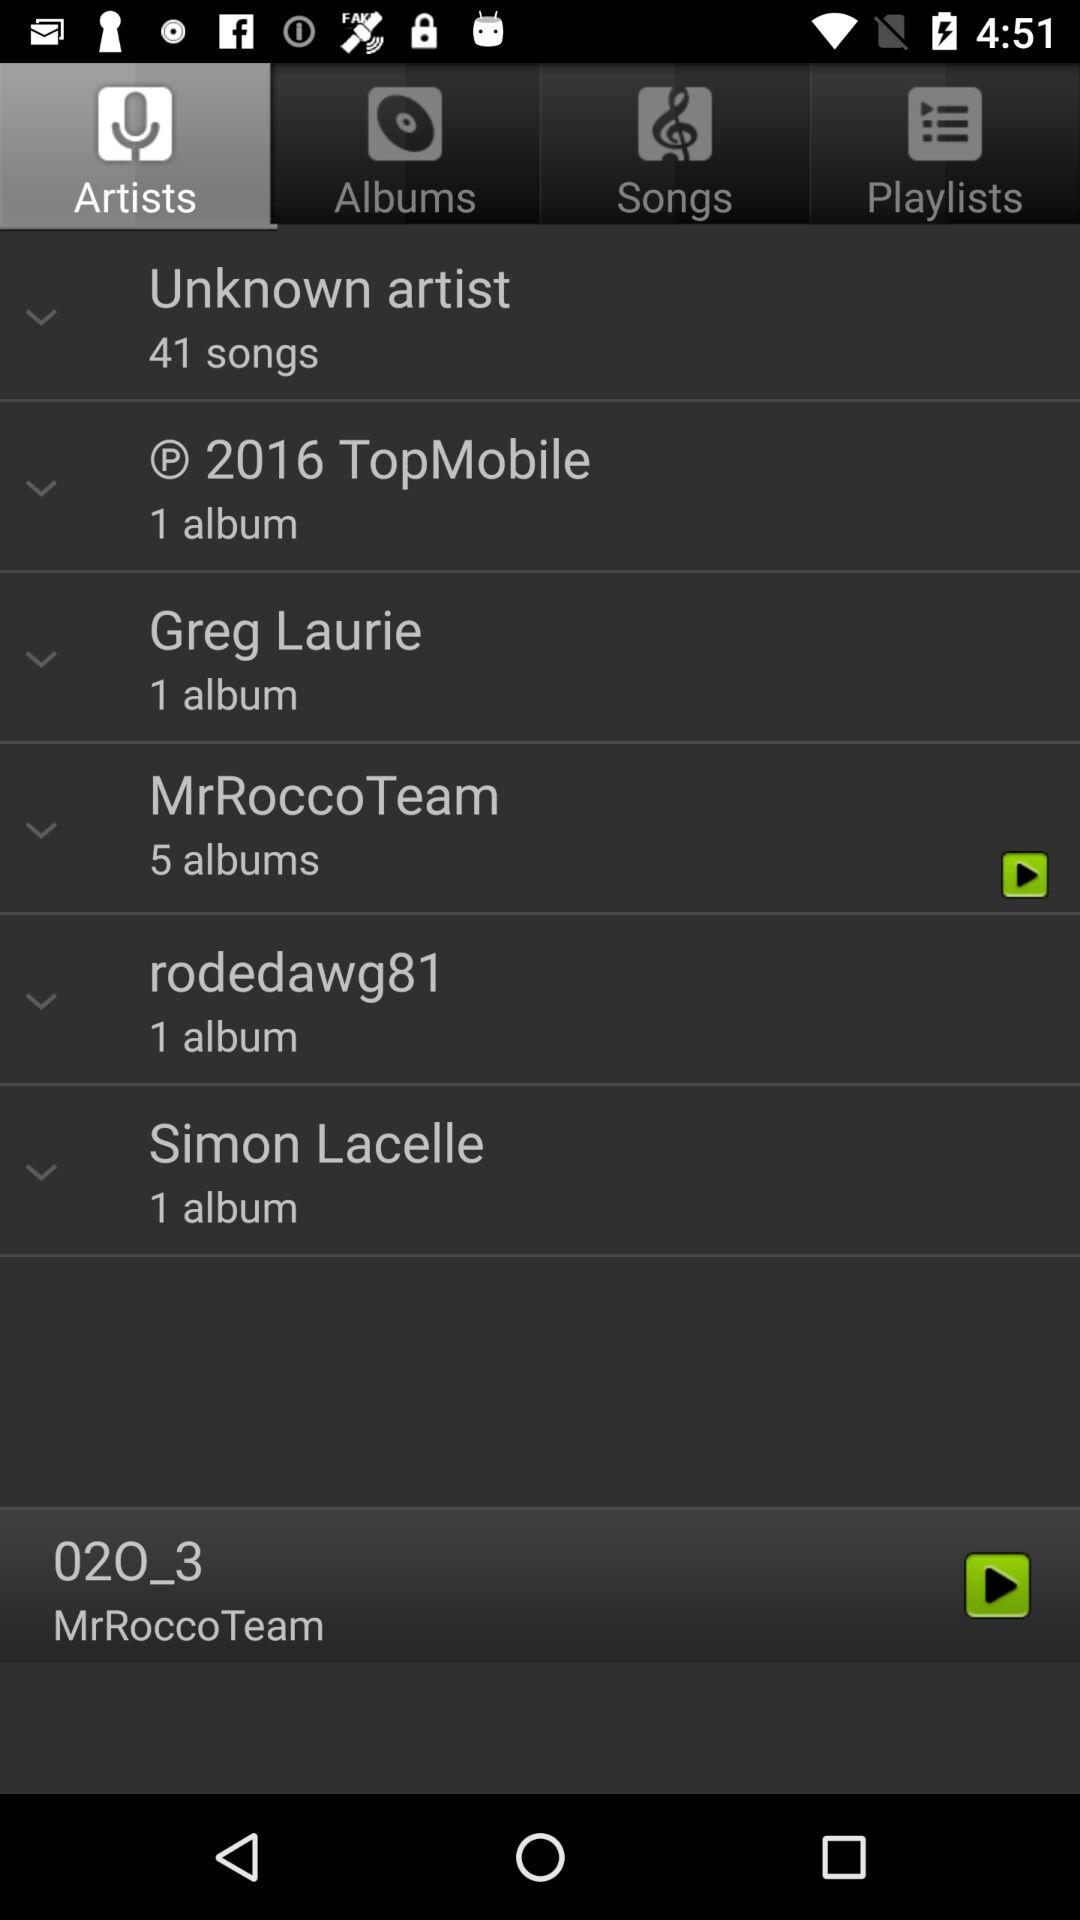How many albums does the artist 'O 2016 TopMobile' have?
Answer the question using a single word or phrase. 1 